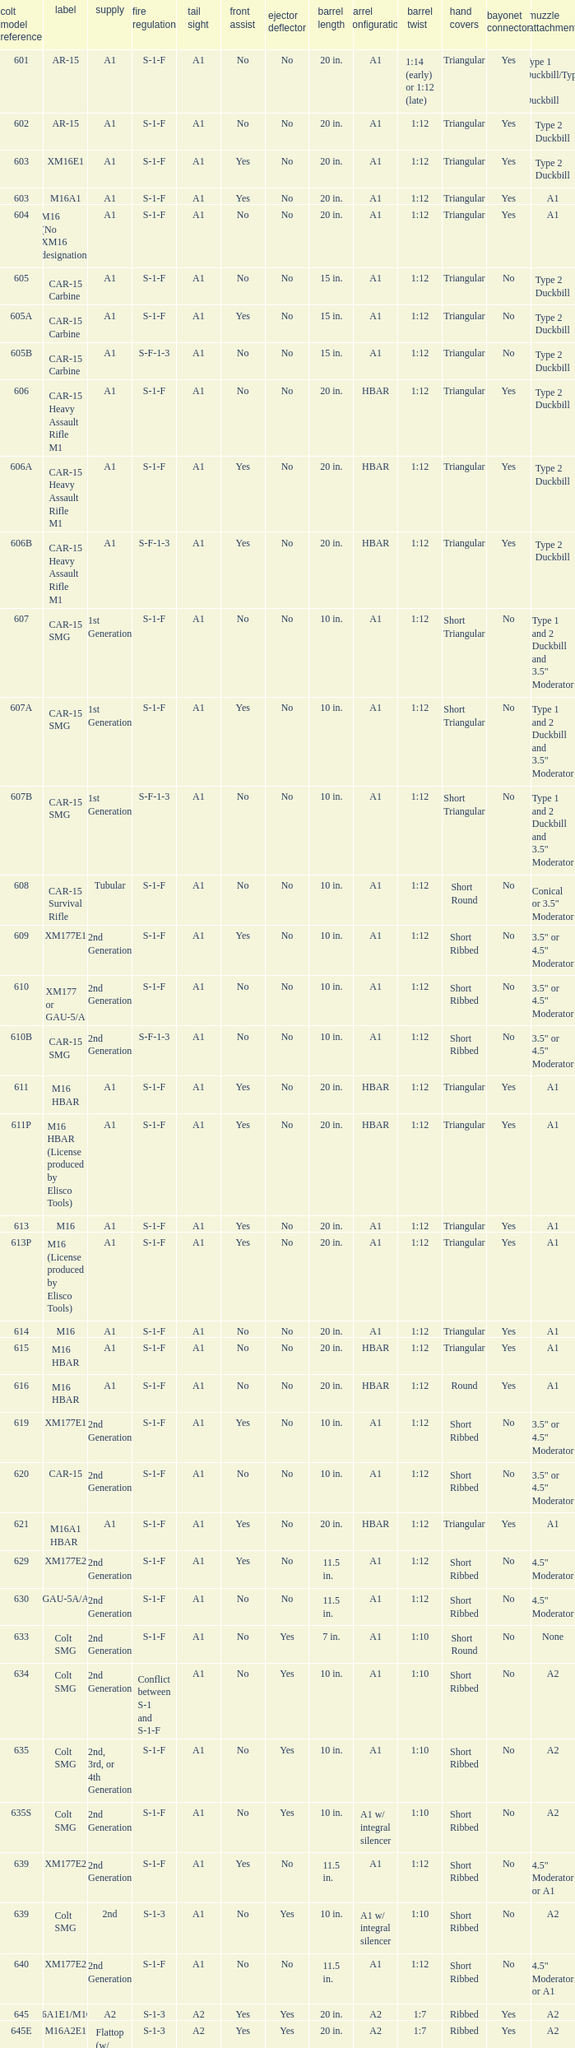What's the type of muzzle devices on the models with round hand guards? A1. 